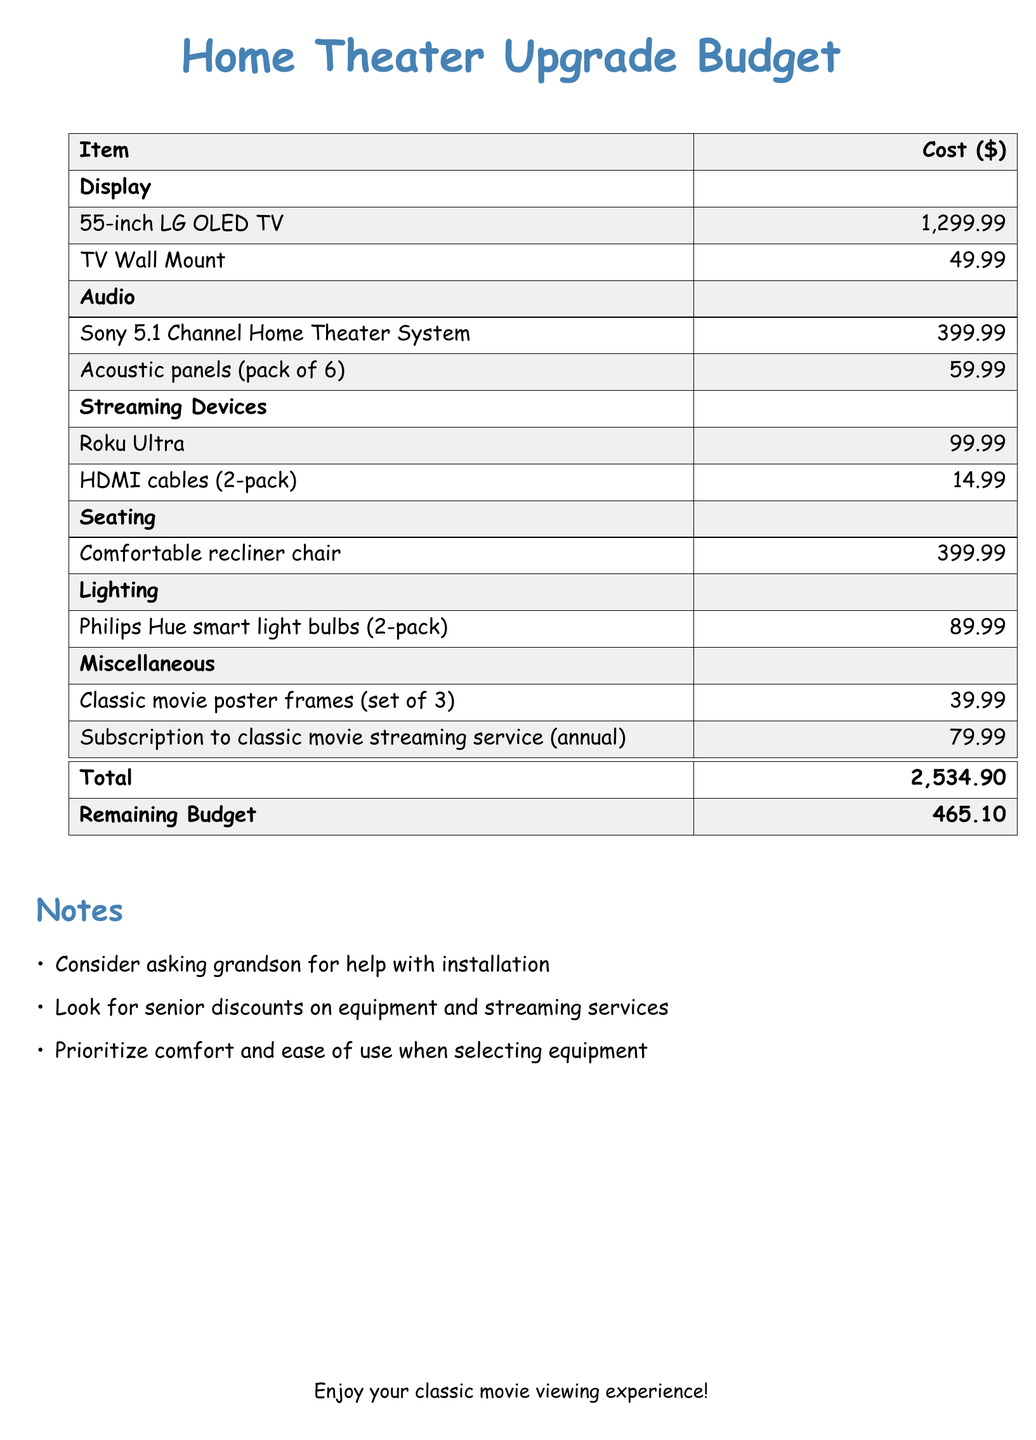What is the total cost of the home theater upgrade? The total cost is the sum of all listed items in the budget, which equals $2,534.90.
Answer: $2,534.90 What is the cost of the 55-inch LG OLED TV? The cost for the 55-inch LG OLED TV is specified in the document as $1,299.99.
Answer: $1,299.99 How much is allocated for the subscription to a classic movie streaming service? The budget allocates $79.99 for the annual subscription to the classic movie streaming service.
Answer: $79.99 What type of audio system is included in the budget? The budget includes a Sony 5.1 Channel Home Theater System as the audio system.
Answer: Sony 5.1 Channel Home Theater System How many acoustic panels are included in the pack? The document specifies that the pack of acoustic panels contains 6 panels.
Answer: 6 What is the remaining budget after the upgrade? The remaining budget, after accounting for all expenses, is noted as $465.10 in the document.
Answer: $465.10 What color are the Philips Hue smart light bulbs? The document does not specify the color of the Philips Hue smart light bulbs, only that they come in a 2-pack.
Answer: (Not specified) What additional item is recommended for improvement of movie viewing? The recommendation for improvement includes comfortable recliner chairs for better seating during movie watching.
Answer: Comfortable recliner chair How many classic movie poster frames are included in the budget? The budget lists a set of 3 classic movie poster frames as a miscellaneous item.
Answer: 3 